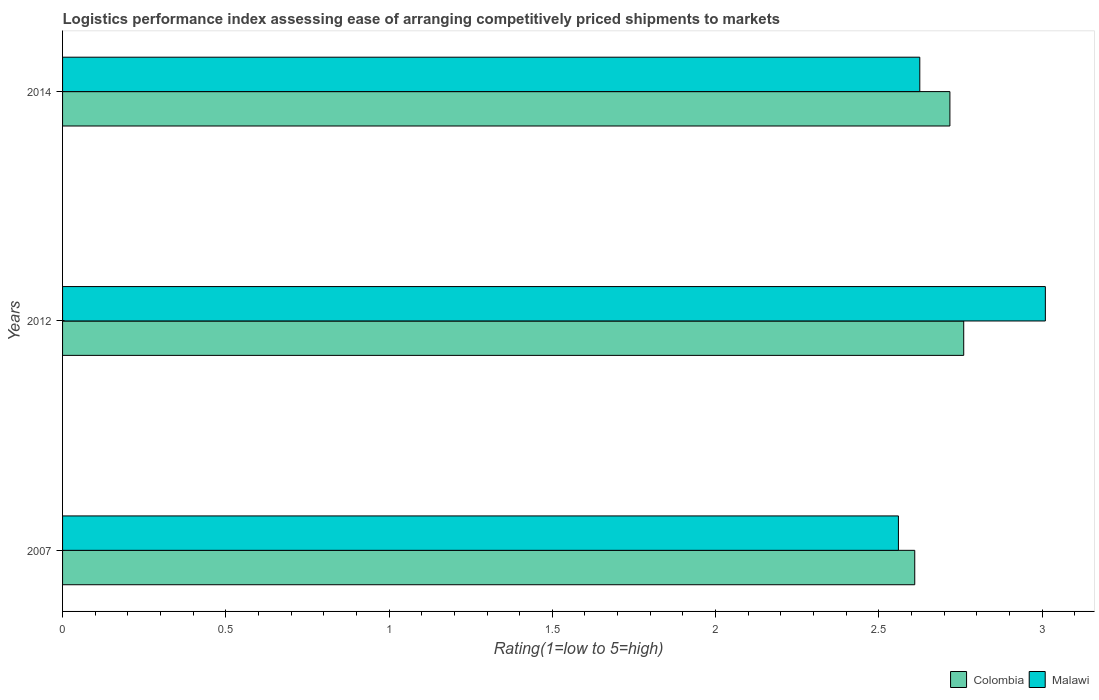What is the label of the 2nd group of bars from the top?
Make the answer very short. 2012. In how many cases, is the number of bars for a given year not equal to the number of legend labels?
Your answer should be compact. 0. What is the Logistic performance index in Malawi in 2007?
Provide a succinct answer. 2.56. Across all years, what is the maximum Logistic performance index in Malawi?
Provide a succinct answer. 3.01. Across all years, what is the minimum Logistic performance index in Malawi?
Your response must be concise. 2.56. In which year was the Logistic performance index in Malawi maximum?
Provide a succinct answer. 2012. In which year was the Logistic performance index in Malawi minimum?
Provide a short and direct response. 2007. What is the total Logistic performance index in Malawi in the graph?
Your answer should be compact. 8.2. What is the difference between the Logistic performance index in Colombia in 2007 and that in 2014?
Provide a short and direct response. -0.11. What is the difference between the Logistic performance index in Malawi in 2014 and the Logistic performance index in Colombia in 2012?
Offer a terse response. -0.13. What is the average Logistic performance index in Colombia per year?
Keep it short and to the point. 2.7. In the year 2007, what is the difference between the Logistic performance index in Malawi and Logistic performance index in Colombia?
Ensure brevity in your answer.  -0.05. What is the ratio of the Logistic performance index in Colombia in 2012 to that in 2014?
Offer a terse response. 1.02. Is the difference between the Logistic performance index in Malawi in 2007 and 2012 greater than the difference between the Logistic performance index in Colombia in 2007 and 2012?
Offer a very short reply. No. What is the difference between the highest and the second highest Logistic performance index in Malawi?
Ensure brevity in your answer.  0.38. What is the difference between the highest and the lowest Logistic performance index in Colombia?
Your answer should be compact. 0.15. What does the 2nd bar from the top in 2012 represents?
Offer a very short reply. Colombia. What does the 1st bar from the bottom in 2014 represents?
Keep it short and to the point. Colombia. How many years are there in the graph?
Offer a very short reply. 3. What is the difference between two consecutive major ticks on the X-axis?
Ensure brevity in your answer.  0.5. Does the graph contain any zero values?
Offer a very short reply. No. What is the title of the graph?
Your answer should be very brief. Logistics performance index assessing ease of arranging competitively priced shipments to markets. What is the label or title of the X-axis?
Offer a terse response. Rating(1=low to 5=high). What is the Rating(1=low to 5=high) in Colombia in 2007?
Your response must be concise. 2.61. What is the Rating(1=low to 5=high) of Malawi in 2007?
Your response must be concise. 2.56. What is the Rating(1=low to 5=high) in Colombia in 2012?
Offer a very short reply. 2.76. What is the Rating(1=low to 5=high) in Malawi in 2012?
Offer a terse response. 3.01. What is the Rating(1=low to 5=high) of Colombia in 2014?
Your answer should be very brief. 2.72. What is the Rating(1=low to 5=high) in Malawi in 2014?
Provide a short and direct response. 2.63. Across all years, what is the maximum Rating(1=low to 5=high) in Colombia?
Your answer should be compact. 2.76. Across all years, what is the maximum Rating(1=low to 5=high) of Malawi?
Your answer should be compact. 3.01. Across all years, what is the minimum Rating(1=low to 5=high) of Colombia?
Your answer should be very brief. 2.61. Across all years, what is the minimum Rating(1=low to 5=high) of Malawi?
Make the answer very short. 2.56. What is the total Rating(1=low to 5=high) of Colombia in the graph?
Your answer should be very brief. 8.09. What is the total Rating(1=low to 5=high) in Malawi in the graph?
Give a very brief answer. 8.2. What is the difference between the Rating(1=low to 5=high) in Colombia in 2007 and that in 2012?
Your answer should be very brief. -0.15. What is the difference between the Rating(1=low to 5=high) of Malawi in 2007 and that in 2012?
Give a very brief answer. -0.45. What is the difference between the Rating(1=low to 5=high) of Colombia in 2007 and that in 2014?
Your answer should be compact. -0.11. What is the difference between the Rating(1=low to 5=high) of Malawi in 2007 and that in 2014?
Ensure brevity in your answer.  -0.07. What is the difference between the Rating(1=low to 5=high) in Colombia in 2012 and that in 2014?
Offer a very short reply. 0.04. What is the difference between the Rating(1=low to 5=high) in Malawi in 2012 and that in 2014?
Give a very brief answer. 0.38. What is the difference between the Rating(1=low to 5=high) in Colombia in 2007 and the Rating(1=low to 5=high) in Malawi in 2014?
Offer a terse response. -0.02. What is the difference between the Rating(1=low to 5=high) in Colombia in 2012 and the Rating(1=low to 5=high) in Malawi in 2014?
Your answer should be compact. 0.13. What is the average Rating(1=low to 5=high) in Colombia per year?
Keep it short and to the point. 2.7. What is the average Rating(1=low to 5=high) of Malawi per year?
Provide a succinct answer. 2.73. In the year 2007, what is the difference between the Rating(1=low to 5=high) of Colombia and Rating(1=low to 5=high) of Malawi?
Ensure brevity in your answer.  0.05. In the year 2014, what is the difference between the Rating(1=low to 5=high) of Colombia and Rating(1=low to 5=high) of Malawi?
Your response must be concise. 0.09. What is the ratio of the Rating(1=low to 5=high) in Colombia in 2007 to that in 2012?
Ensure brevity in your answer.  0.95. What is the ratio of the Rating(1=low to 5=high) of Malawi in 2007 to that in 2012?
Offer a terse response. 0.85. What is the ratio of the Rating(1=low to 5=high) of Colombia in 2007 to that in 2014?
Make the answer very short. 0.96. What is the ratio of the Rating(1=low to 5=high) of Malawi in 2007 to that in 2014?
Give a very brief answer. 0.98. What is the ratio of the Rating(1=low to 5=high) in Colombia in 2012 to that in 2014?
Provide a short and direct response. 1.02. What is the ratio of the Rating(1=low to 5=high) in Malawi in 2012 to that in 2014?
Offer a very short reply. 1.15. What is the difference between the highest and the second highest Rating(1=low to 5=high) of Colombia?
Ensure brevity in your answer.  0.04. What is the difference between the highest and the second highest Rating(1=low to 5=high) in Malawi?
Keep it short and to the point. 0.38. What is the difference between the highest and the lowest Rating(1=low to 5=high) of Malawi?
Provide a short and direct response. 0.45. 